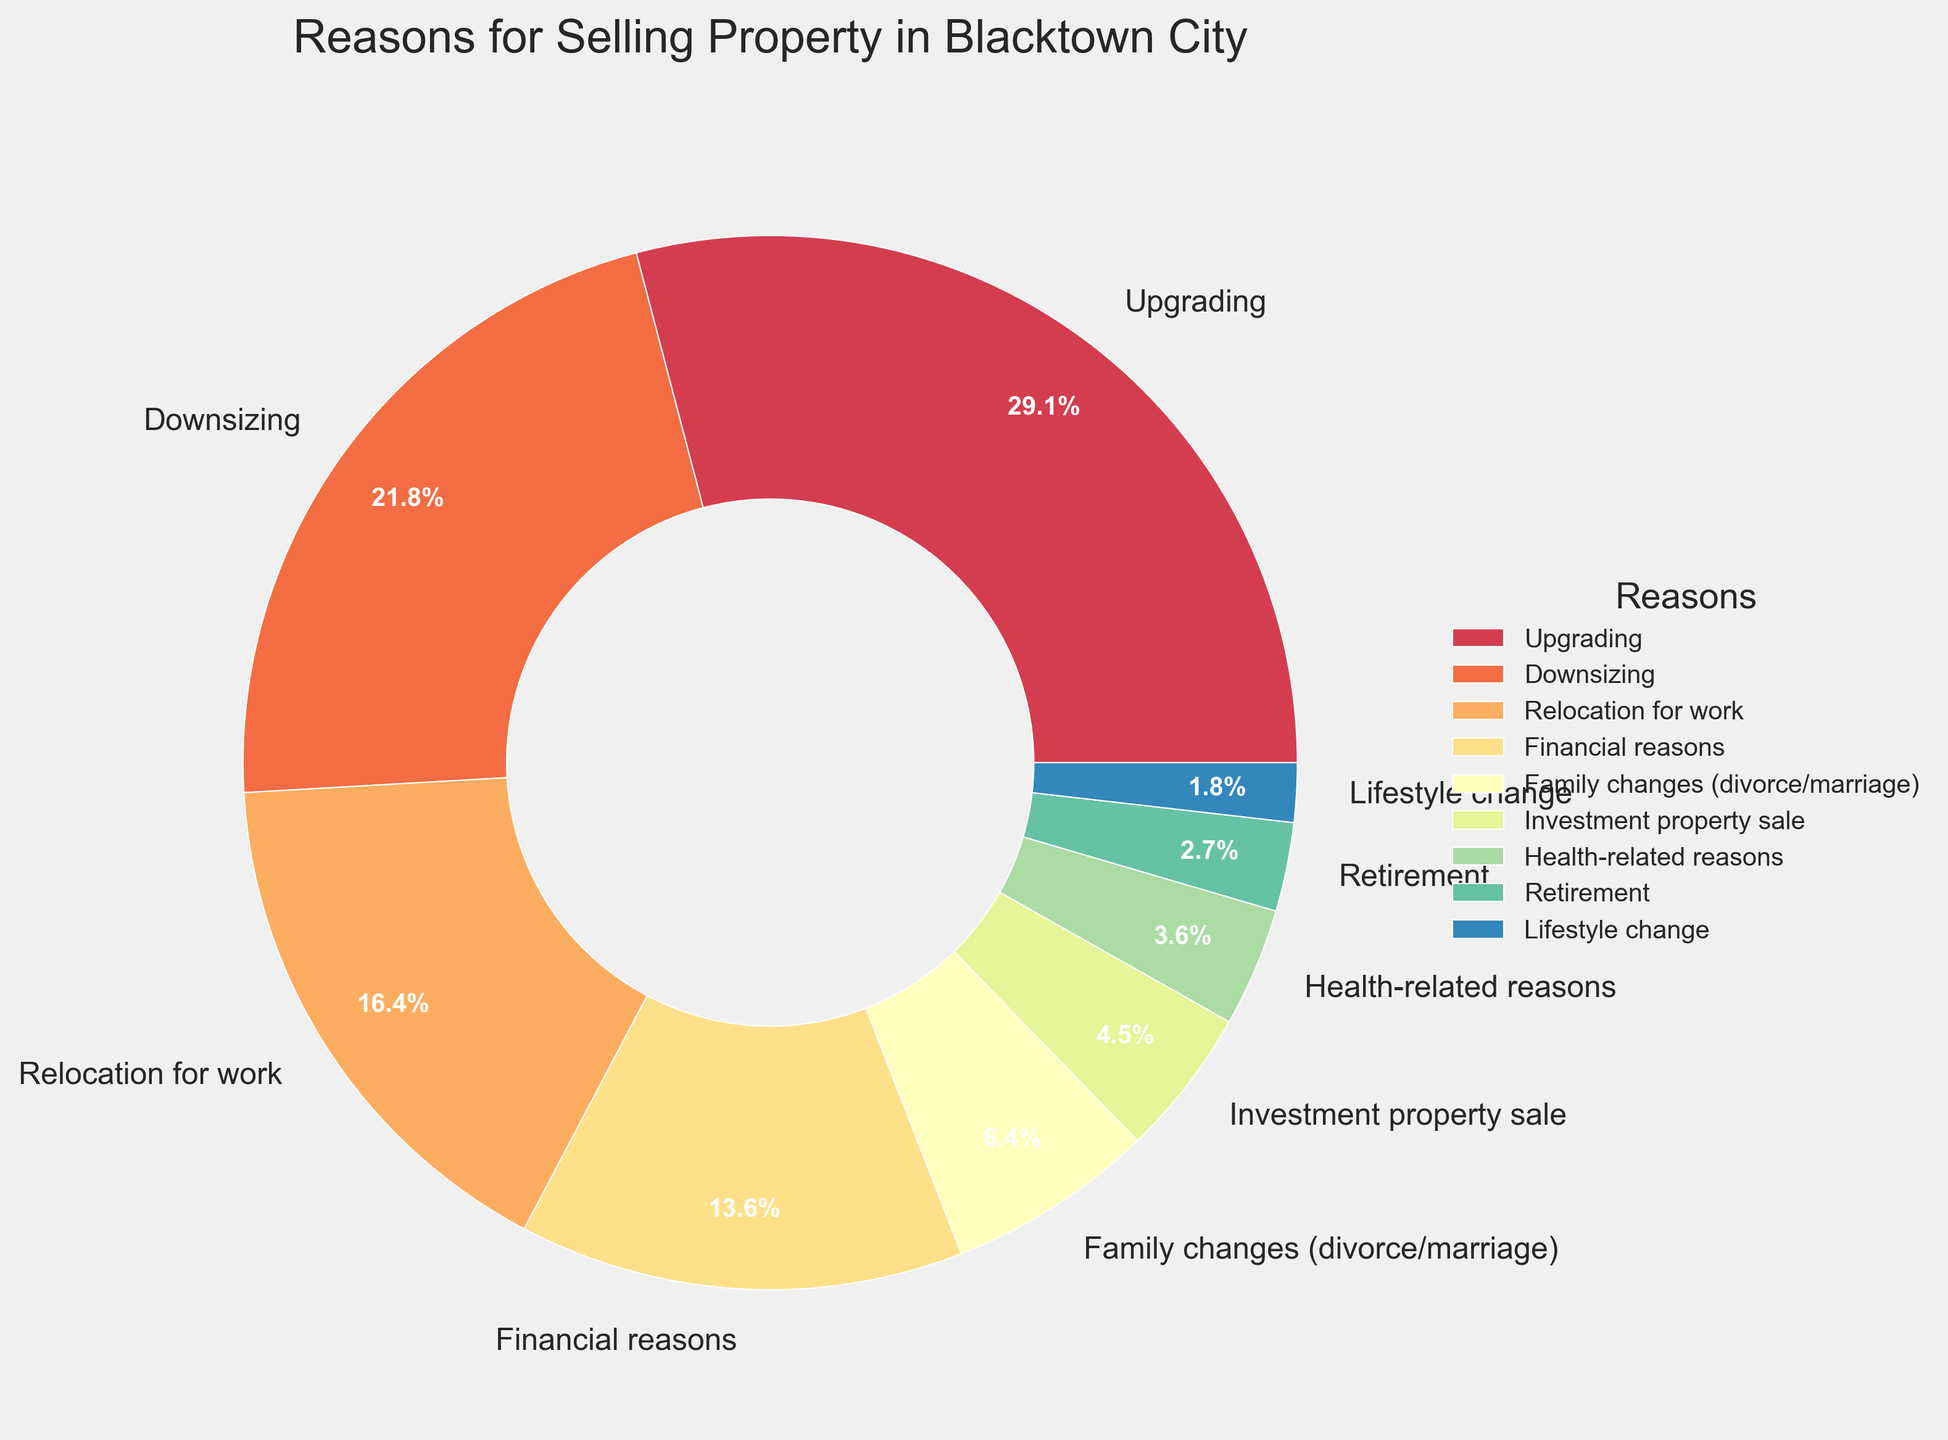What is the most common reason for selling a property in Blacktown City? By looking at the pie chart, the segment with the highest percentage represents the most common reason. "Upgrading" has the largest segment with 32%.
Answer: Upgrading What percentage of property sales are due to financial reasons compared to family changes? Compare the percentages of "Financial reasons" and "Family changes (divorce/marriage)" segments. Financial reasons account for 15%, while family changes account for 7%.
Answer: 15% vs 7% How much more frequently do people sell their property due to upgrading compared to downsizing? Subtract the percentage of downsizing from the percentage of upgrading. Upgrading is 32% and downsizing is 24%. So, 32% - 24% = 8%.
Answer: 8% What is the percentage of property sales due to reasons other than upgrading, downsizing, and relocation for work? Sum the percentages of all other reasons: 15% (Financial) + 7% (Family changes) + 5% (Investment) + 4% (Health) + 3% (Retirement) + 2% (Lifestyle) = 36%.
Answer: 36% Are there more property sales for relocation for work or for investment property sales? Compare the percentages of "Relocation for work" and "Investment property sale". Relocation for work is 18%, while investment property sale is 5%.
Answer: Relocation for work What are the least common reasons for selling a property? The smallest segments in the pie chart represent the least common reasons. "Lifestyle change" at 2% and "Retirement" at 3% are the least common.
Answer: Lifestyle change and Retirement If 10,000 properties were sold, how many were due to health-related reasons? Use the percentage for health-related reasons to find the number of properties: 4% of 10,000 = 0.04 * 10,000 = 400.
Answer: 400 Which reasons together account for over half of the property sales? Identify reasons whose combined percentages exceed 50%. Upgrading (32%) + Downsizing (24%) = 56% which is over half.
Answer: Upgrading and Downsizing Comparing financial reasons and health-related reasons, which one accounts for a higher percentage of property sales, and by how much? Compare the percentages of financial reasons (15%) and health-related reasons (4%). 15% - 4% = 11%. Financial reasons account for 11% more sales.
Answer: Financial reasons by 11% How do property sales due to family changes compare to those due to lifestyle changes? Compare the percentages of family changes (7%) with lifestyle changes (2%). Family changes are more common.
Answer: Family changes 